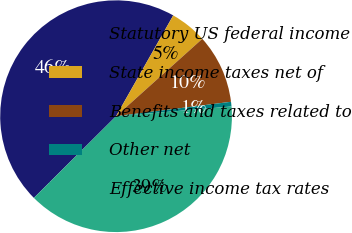<chart> <loc_0><loc_0><loc_500><loc_500><pie_chart><fcel>Statutory US federal income<fcel>State income taxes net of<fcel>Benefits and taxes related to<fcel>Other net<fcel>Effective income tax rates<nl><fcel>45.66%<fcel>5.15%<fcel>9.65%<fcel>0.65%<fcel>38.88%<nl></chart> 